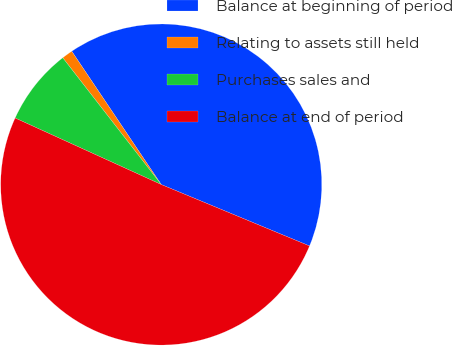Convert chart to OTSL. <chart><loc_0><loc_0><loc_500><loc_500><pie_chart><fcel>Balance at beginning of period<fcel>Relating to assets still held<fcel>Purchases sales and<fcel>Balance at end of period<nl><fcel>40.66%<fcel>1.1%<fcel>7.69%<fcel>50.55%<nl></chart> 